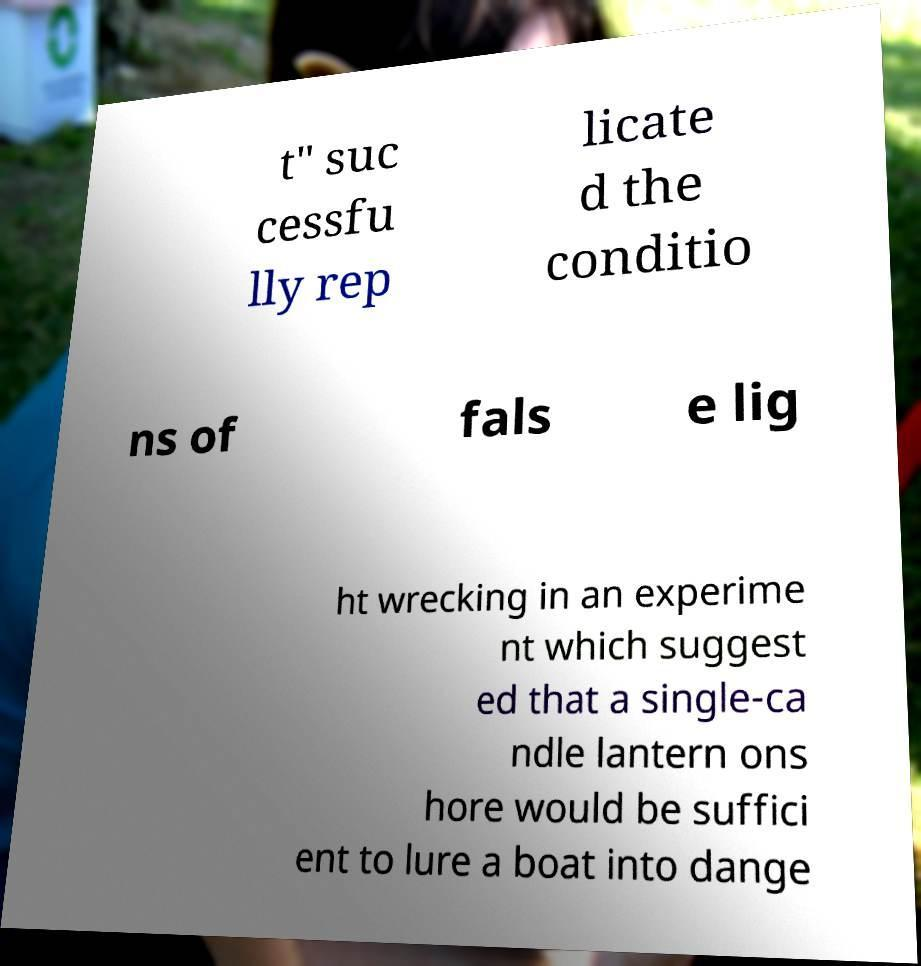Can you read and provide the text displayed in the image?This photo seems to have some interesting text. Can you extract and type it out for me? t" suc cessfu lly rep licate d the conditio ns of fals e lig ht wrecking in an experime nt which suggest ed that a single-ca ndle lantern ons hore would be suffici ent to lure a boat into dange 